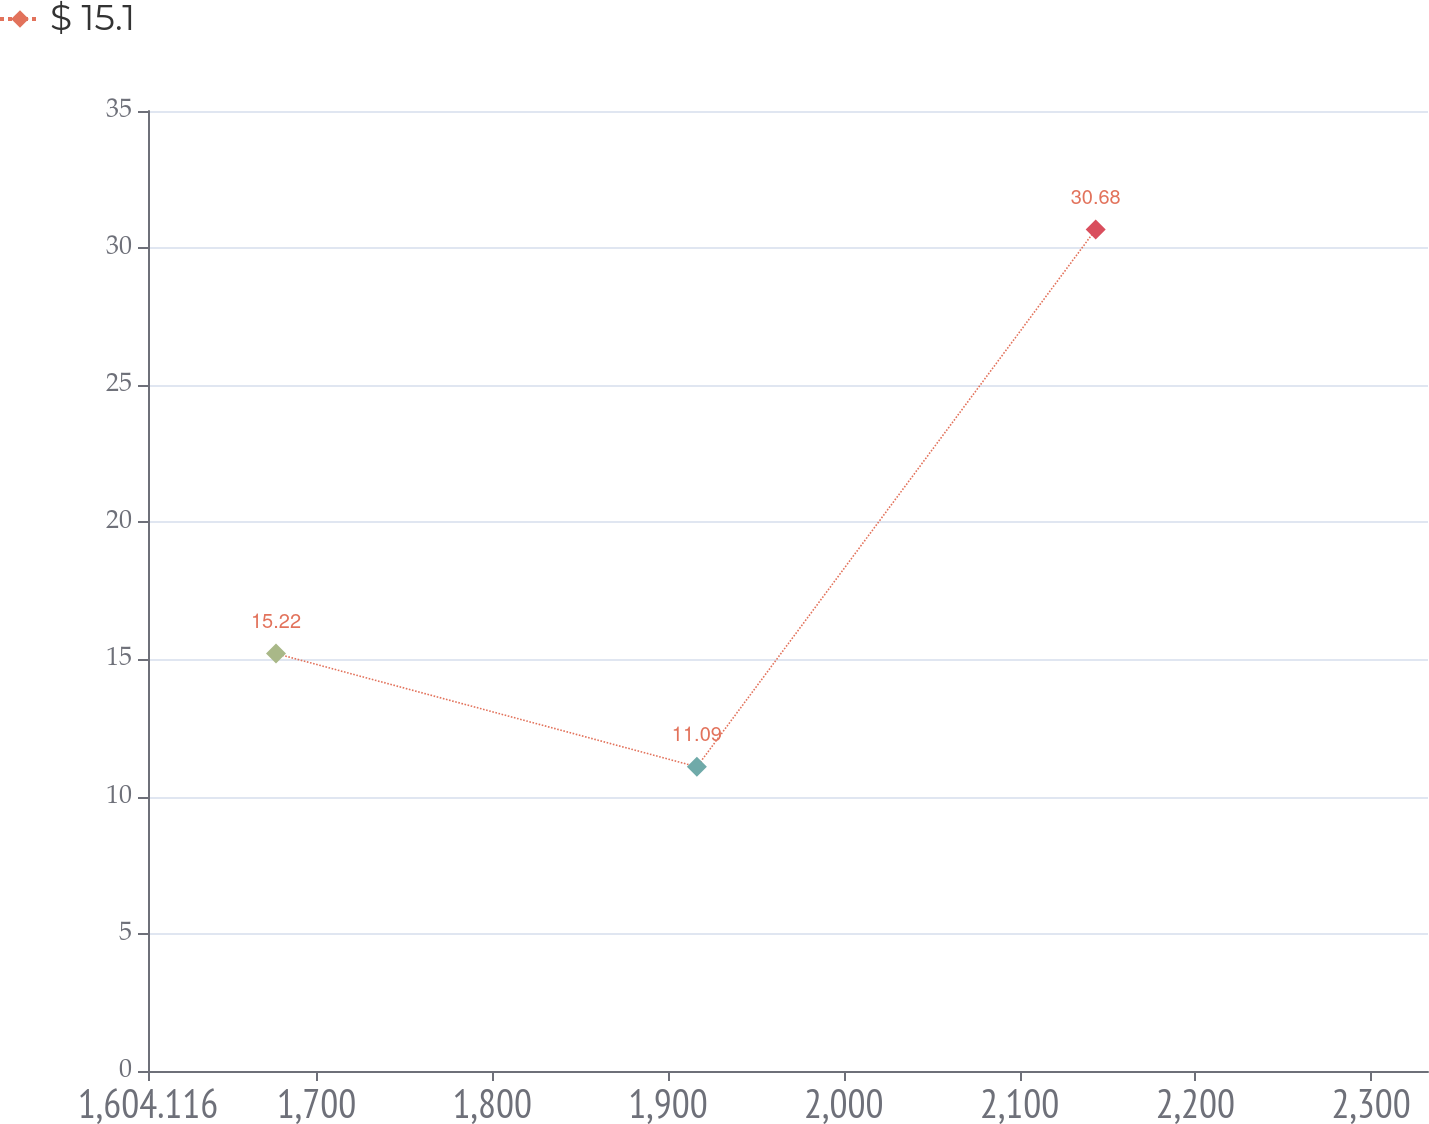<chart> <loc_0><loc_0><loc_500><loc_500><line_chart><ecel><fcel>$ 15.1<nl><fcel>1676.94<fcel>15.22<nl><fcel>1916.39<fcel>11.09<nl><fcel>2143.28<fcel>30.68<nl><fcel>2405.18<fcel>8.91<nl></chart> 